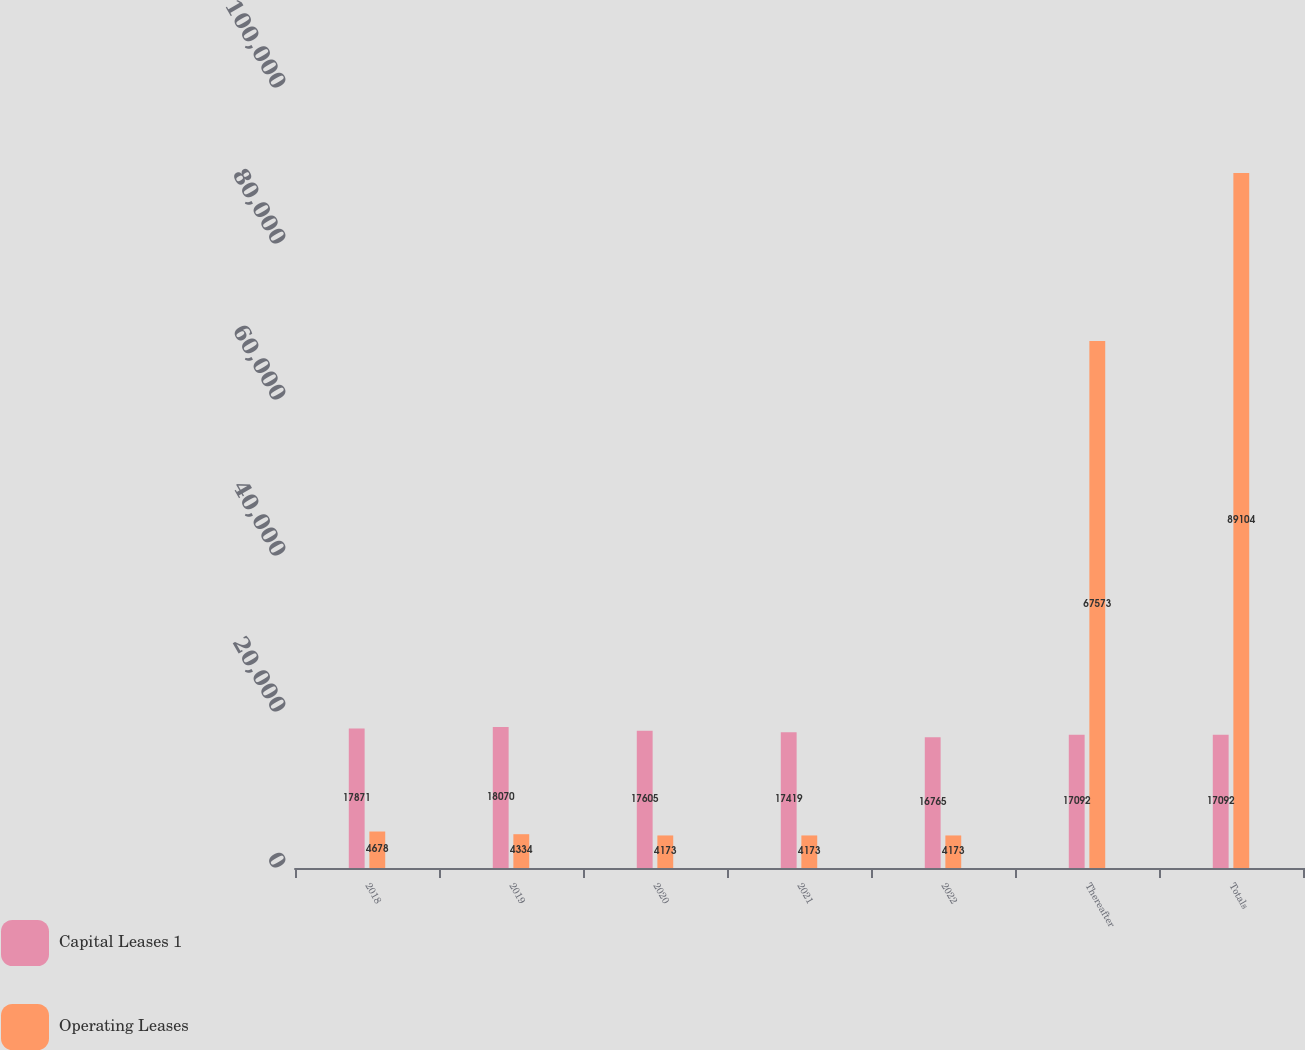<chart> <loc_0><loc_0><loc_500><loc_500><stacked_bar_chart><ecel><fcel>2018<fcel>2019<fcel>2020<fcel>2021<fcel>2022<fcel>Thereafter<fcel>Totals<nl><fcel>Capital Leases 1<fcel>17871<fcel>18070<fcel>17605<fcel>17419<fcel>16765<fcel>17092<fcel>17092<nl><fcel>Operating Leases<fcel>4678<fcel>4334<fcel>4173<fcel>4173<fcel>4173<fcel>67573<fcel>89104<nl></chart> 